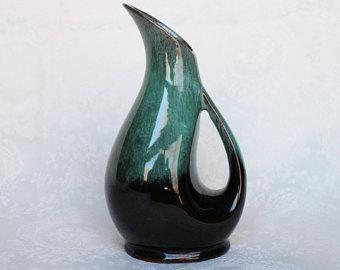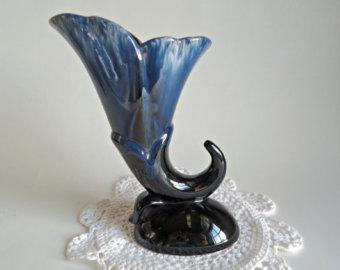The first image is the image on the left, the second image is the image on the right. Assess this claim about the two images: "In one image, a vase with floral petal top design and scroll at the bottom is positioned in the center of a doily.". Correct or not? Answer yes or no. Yes. The first image is the image on the left, the second image is the image on the right. Assess this claim about the two images: "The right image features a matched pair of vases.". Correct or not? Answer yes or no. No. 